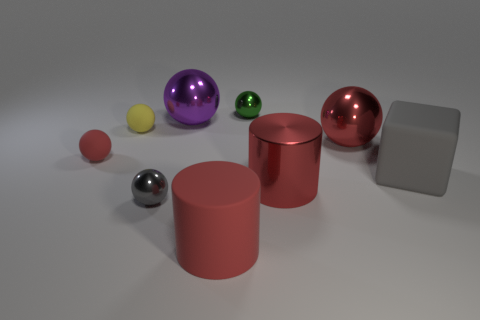There is another big cylinder that is the same color as the metal cylinder; what material is it?
Make the answer very short. Rubber. What number of other objects are the same color as the matte cube?
Your answer should be compact. 1. What is the big purple object made of?
Ensure brevity in your answer.  Metal. How many other things are there of the same material as the small green thing?
Give a very brief answer. 4. There is a thing that is both in front of the red metal cylinder and on the right side of the big purple metallic ball; what size is it?
Provide a succinct answer. Large. There is a tiny matte object that is to the left of the tiny matte ball that is behind the red shiny ball; what is its shape?
Give a very brief answer. Sphere. Is there anything else that is the same shape as the tiny green metal object?
Offer a very short reply. Yes. Is the number of large red metal things behind the large red metallic ball the same as the number of large gray cubes?
Keep it short and to the point. No. There is a big shiny cylinder; is its color the same as the tiny metallic object behind the small red ball?
Offer a very short reply. No. What is the color of the thing that is behind the small gray metal ball and in front of the big gray rubber cube?
Offer a terse response. Red. 